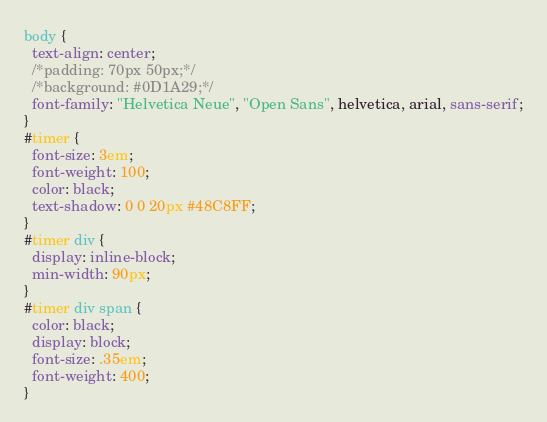Convert code to text. <code><loc_0><loc_0><loc_500><loc_500><_CSS_>body {
  text-align: center;
  /*padding: 70px 50px;*/
  /*background: #0D1A29;*/
  font-family: "Helvetica Neue", "Open Sans", helvetica, arial, sans-serif;
}
#timer {
  font-size: 3em;
  font-weight: 100;
  color: black;
  text-shadow: 0 0 20px #48C8FF;
}
#timer div {
  display: inline-block;
  min-width: 90px;
}
#timer div span {
  color: black;
  display: block;
  font-size: .35em;
  font-weight: 400;
}
</code> 